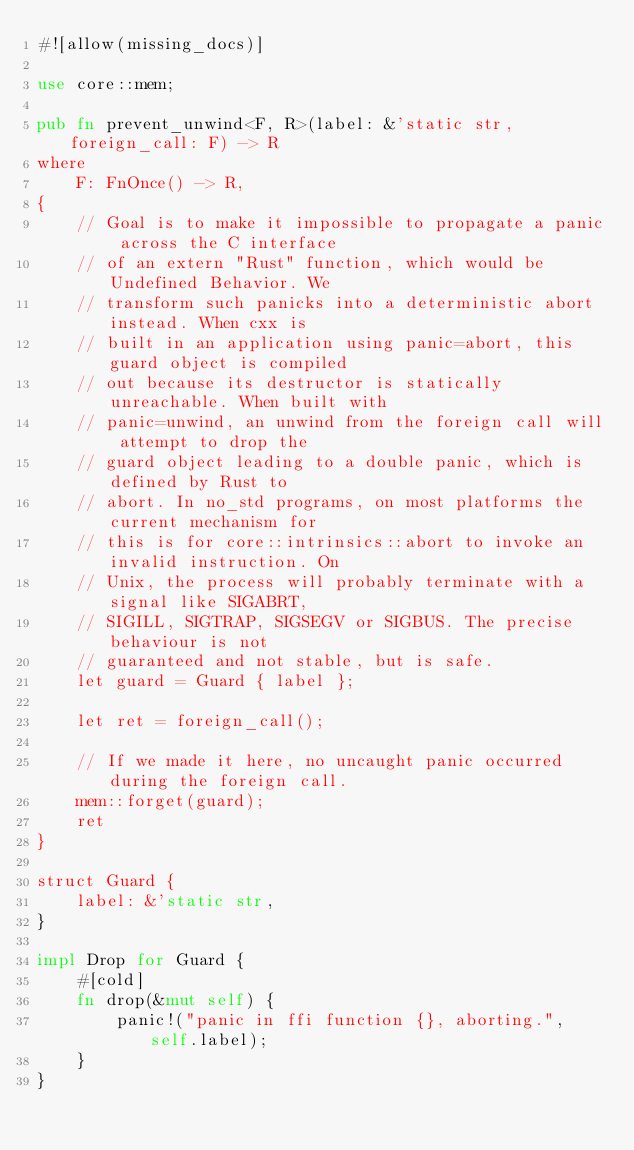Convert code to text. <code><loc_0><loc_0><loc_500><loc_500><_Rust_>#![allow(missing_docs)]

use core::mem;

pub fn prevent_unwind<F, R>(label: &'static str, foreign_call: F) -> R
where
    F: FnOnce() -> R,
{
    // Goal is to make it impossible to propagate a panic across the C interface
    // of an extern "Rust" function, which would be Undefined Behavior. We
    // transform such panicks into a deterministic abort instead. When cxx is
    // built in an application using panic=abort, this guard object is compiled
    // out because its destructor is statically unreachable. When built with
    // panic=unwind, an unwind from the foreign call will attempt to drop the
    // guard object leading to a double panic, which is defined by Rust to
    // abort. In no_std programs, on most platforms the current mechanism for
    // this is for core::intrinsics::abort to invoke an invalid instruction. On
    // Unix, the process will probably terminate with a signal like SIGABRT,
    // SIGILL, SIGTRAP, SIGSEGV or SIGBUS. The precise behaviour is not
    // guaranteed and not stable, but is safe.
    let guard = Guard { label };

    let ret = foreign_call();

    // If we made it here, no uncaught panic occurred during the foreign call.
    mem::forget(guard);
    ret
}

struct Guard {
    label: &'static str,
}

impl Drop for Guard {
    #[cold]
    fn drop(&mut self) {
        panic!("panic in ffi function {}, aborting.", self.label);
    }
}
</code> 